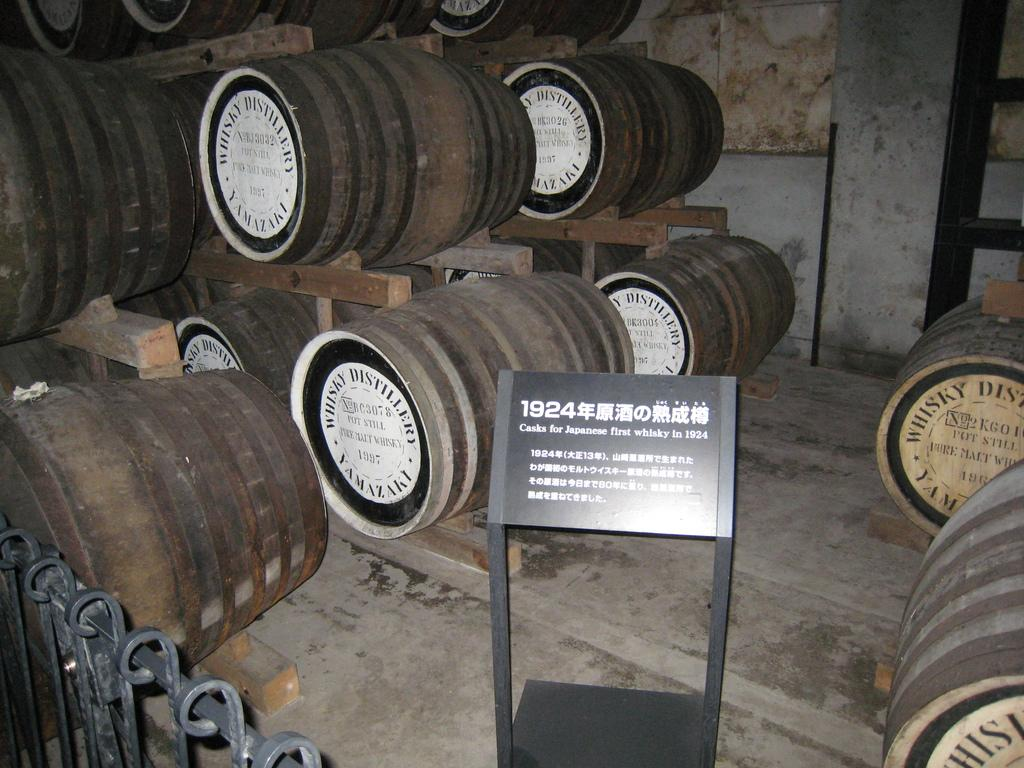What type of objects are made of wood in the image? There are wooden barrels in the image. What type of structure can be seen in the image? There is a fence in the image. What is the wooden structure with text on it in the image? There is a stand board with some text in the image. Can you see any skateboards being used in the image? There are no skateboards present in the image. What type of office equipment can be seen in the image? There is no office equipment present in the image. Are there any fowl visible in the image? There are no fowl visible in the image. 